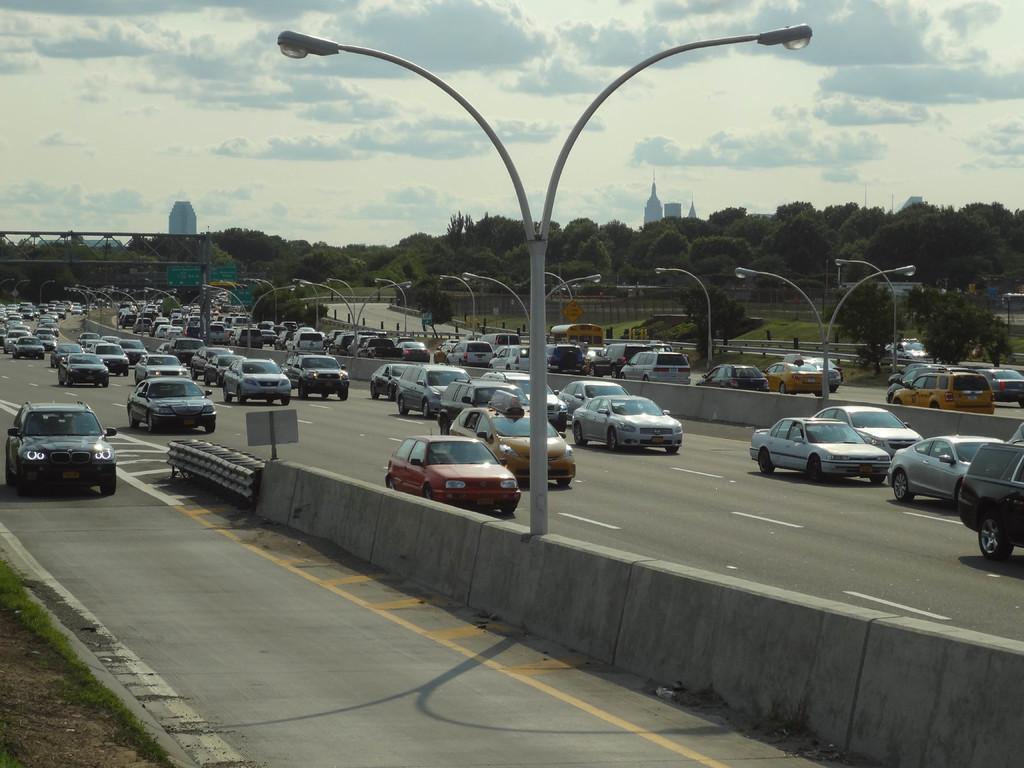In one or two sentences, can you explain what this image depicts? In the center of the image there is a streetlight. There is a road. There are many cars on the road. In the background of the image there are many trees and buildings. 